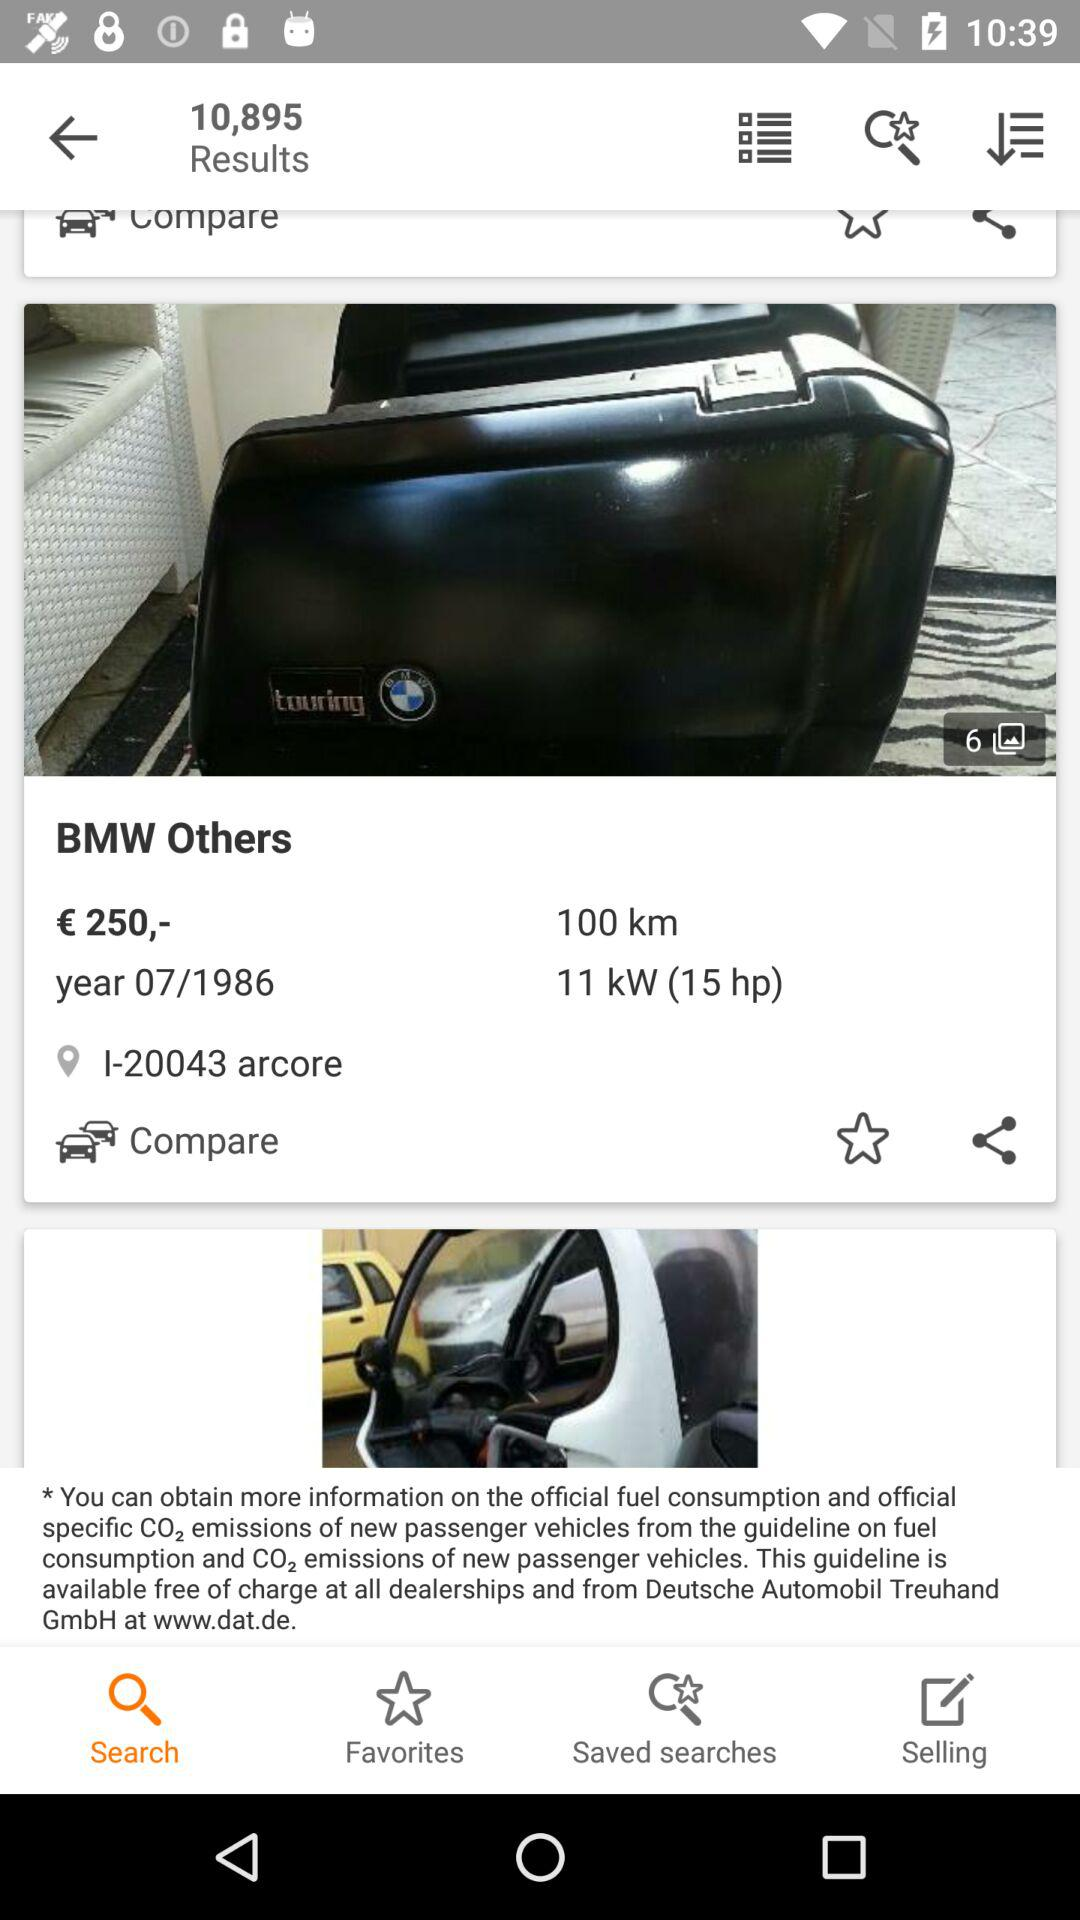How many photos are there? There are 6 photos. 